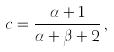<formula> <loc_0><loc_0><loc_500><loc_500>c = \frac { \alpha + 1 } { \alpha + \beta + 2 } \, ,</formula> 